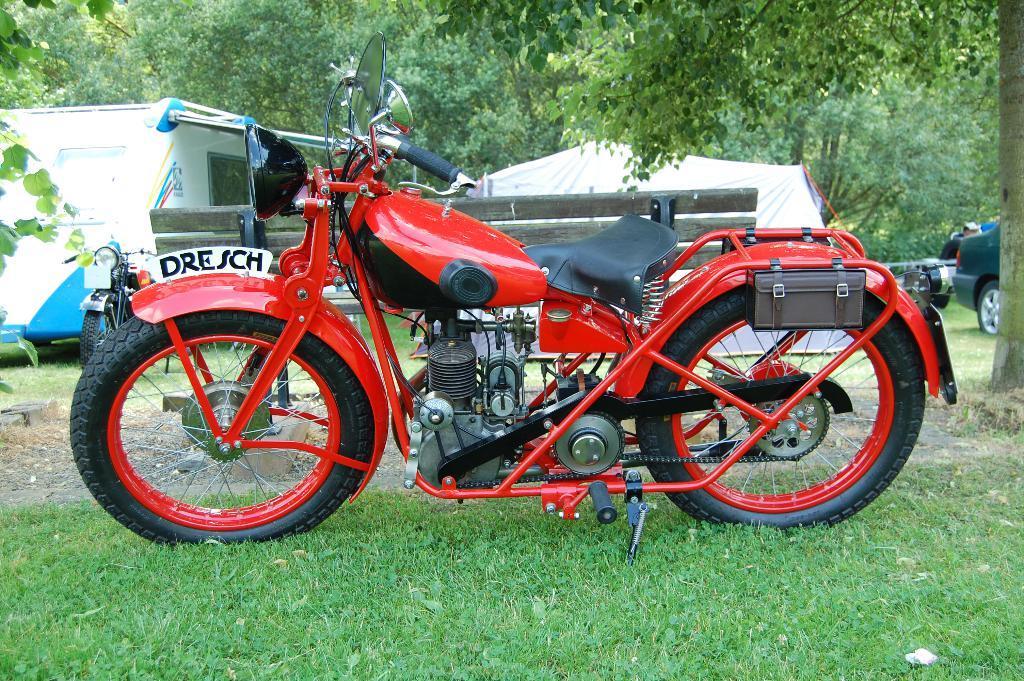In one or two sentences, can you explain what this image depicts? In the middle of this image, there is a red color bike parked on the ground, on which there is grass. In the background, there is a tent, there are vehicles, trees and grass on the ground. 